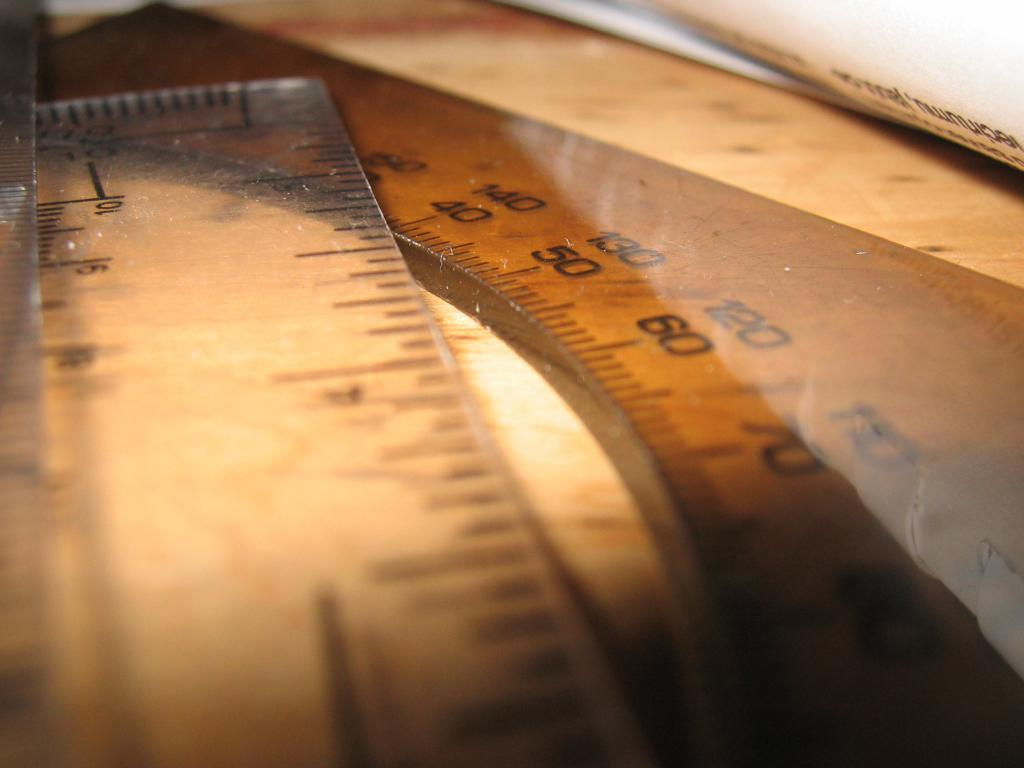<image>
Relay a brief, clear account of the picture shown. Multiply rulers with black measuring lines and a black 60 printed on it. 